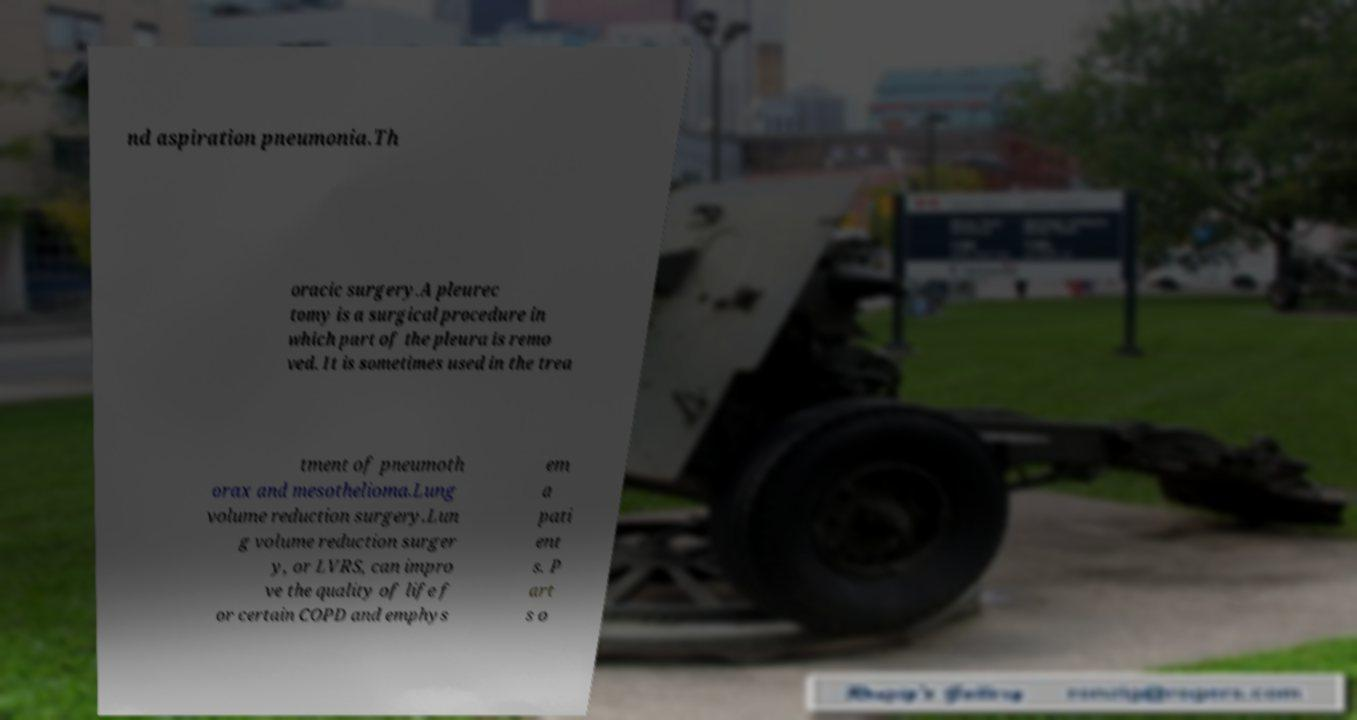Please identify and transcribe the text found in this image. nd aspiration pneumonia.Th oracic surgery.A pleurec tomy is a surgical procedure in which part of the pleura is remo ved. It is sometimes used in the trea tment of pneumoth orax and mesothelioma.Lung volume reduction surgery.Lun g volume reduction surger y, or LVRS, can impro ve the quality of life f or certain COPD and emphys em a pati ent s. P art s o 